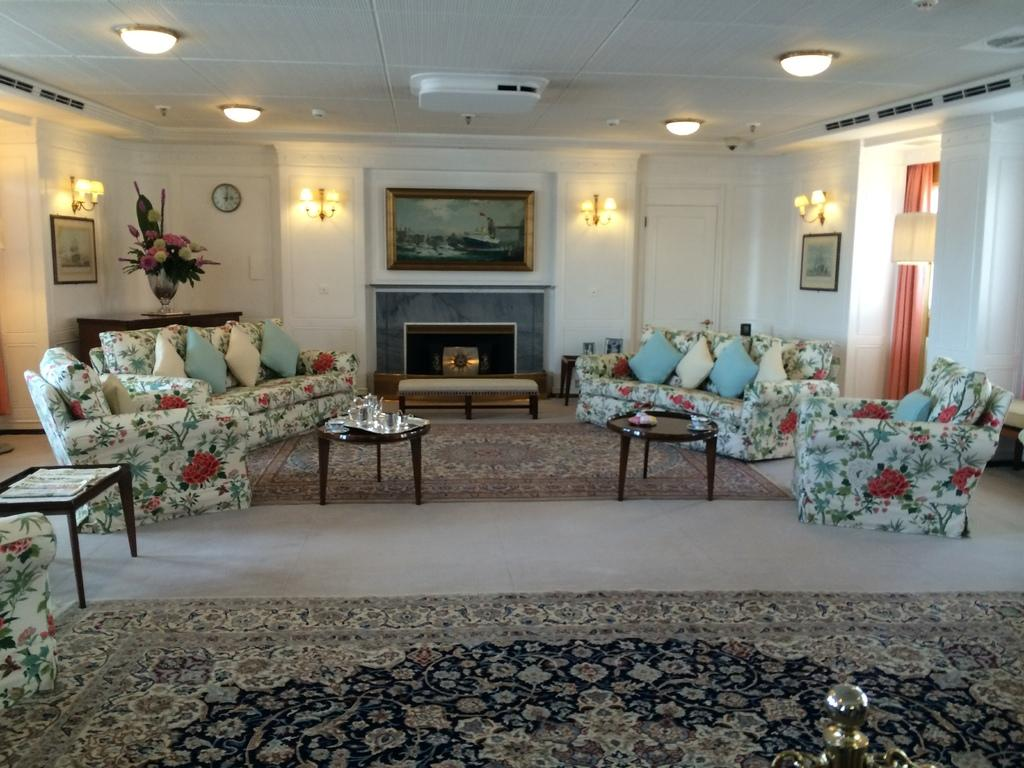What type of room is depicted in the image? The image depicts a living room. What furniture is present in the living room? There is a sofa and a table in the living room. What items can be seen on the table? There are different items present on the table. What time-related object is in the living room? There is a wall clock in the living room. What type of lighting is present in the living room? There are lamps in the living room. What type of decorative items are in the living room? There are frames in the living room. What type of floral arrangement is in the living room? There is a flower vase in the living room. What type of window treatment is in the living room? There are curtains in the living room. Where is the kettle located in the living room? There is no kettle present in the living room. What type of show is being performed in the living room? There is no show being performed in the living room. Is there any smoke visible in the living room? There is no smoke visible in the living room. 